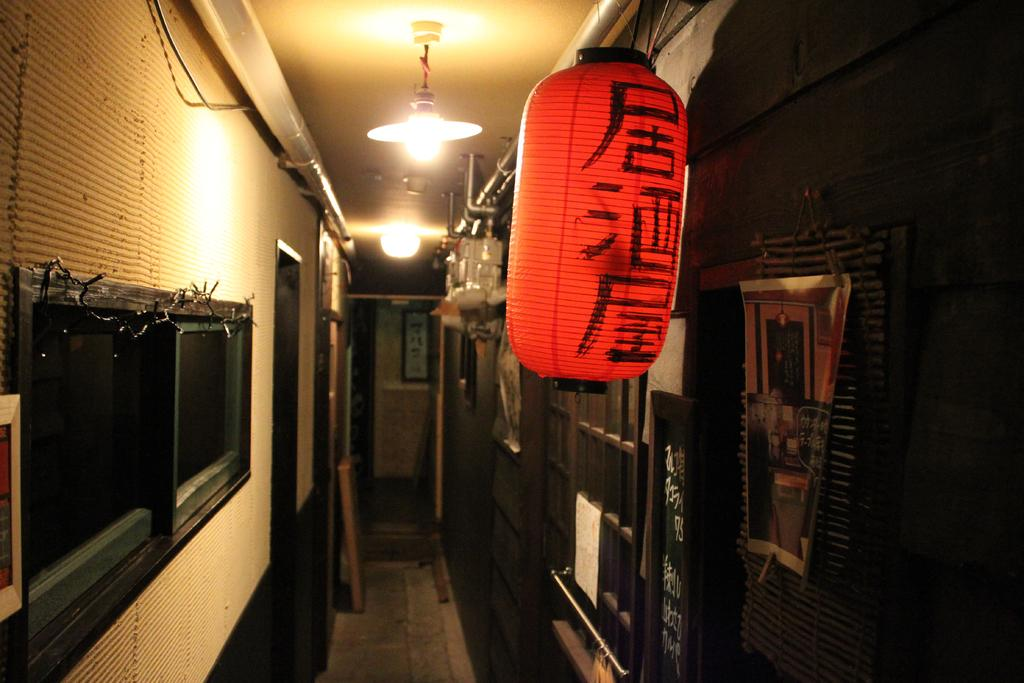What type of structures can be seen in the image? There are walls with windows in the image. What is displayed on the walls in the image? There are posters with text in the image. What type of lighting is present in the image? There are lights on the ceiling in the image. What other items can be seen in the image? There are other items visible in the image, but their specific nature is not mentioned in the provided facts. What type of drum is being played in the image? There is no drum present in the image. What is the message of hate conveyed by the posters in the image? There is no mention of hate or any negative message in the provided facts, and the content of the posters is not specified. 